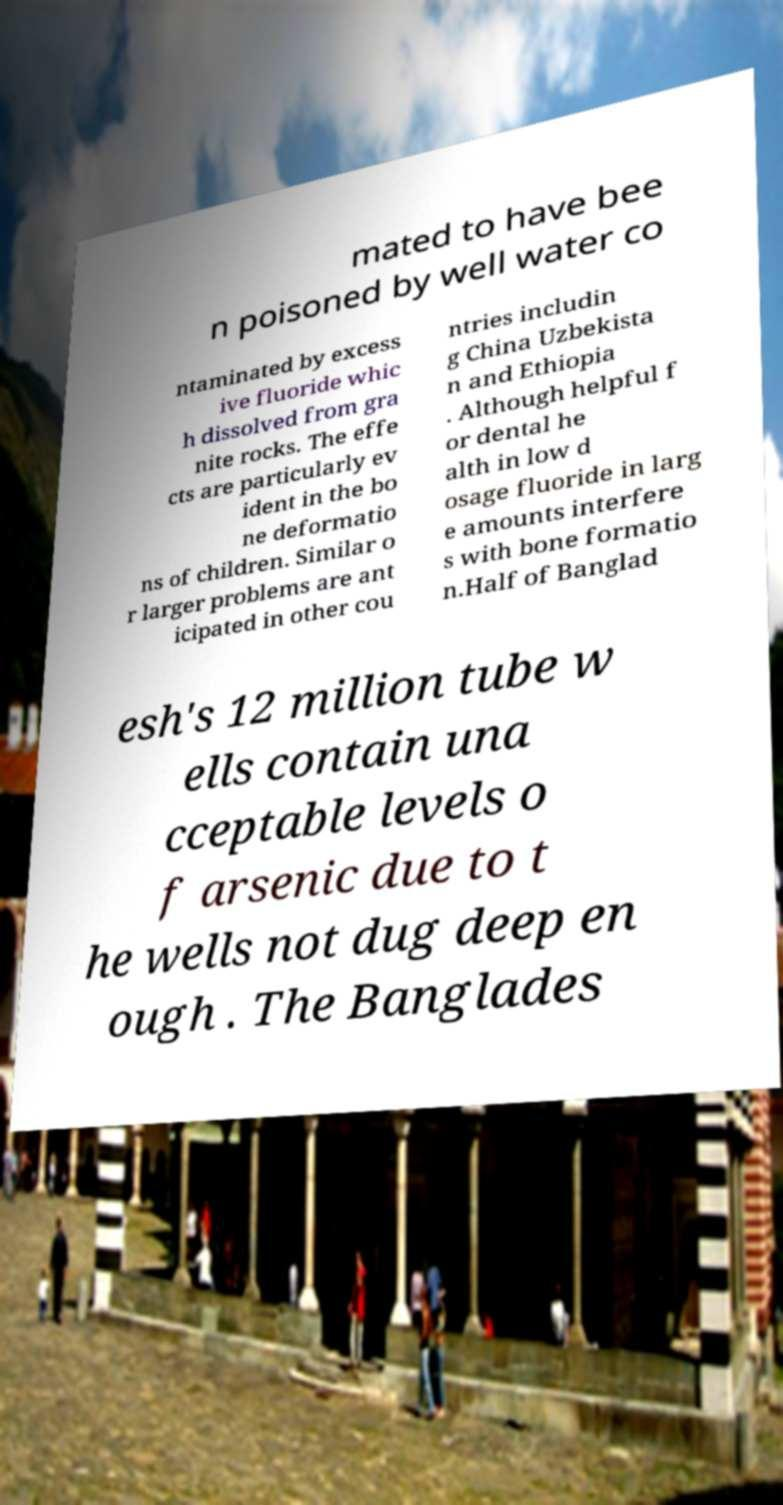For documentation purposes, I need the text within this image transcribed. Could you provide that? mated to have bee n poisoned by well water co ntaminated by excess ive fluoride whic h dissolved from gra nite rocks. The effe cts are particularly ev ident in the bo ne deformatio ns of children. Similar o r larger problems are ant icipated in other cou ntries includin g China Uzbekista n and Ethiopia . Although helpful f or dental he alth in low d osage fluoride in larg e amounts interfere s with bone formatio n.Half of Banglad esh's 12 million tube w ells contain una cceptable levels o f arsenic due to t he wells not dug deep en ough . The Banglades 